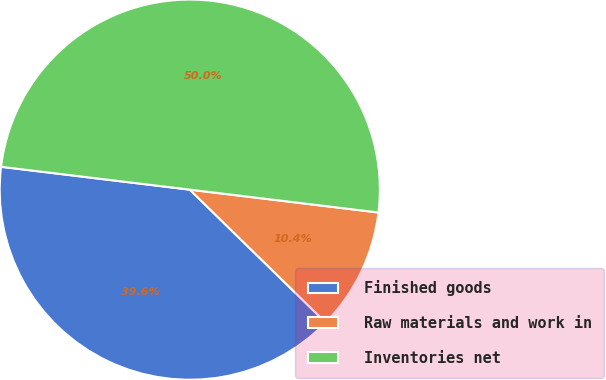<chart> <loc_0><loc_0><loc_500><loc_500><pie_chart><fcel>Finished goods<fcel>Raw materials and work in<fcel>Inventories net<nl><fcel>39.6%<fcel>10.4%<fcel>50.0%<nl></chart> 